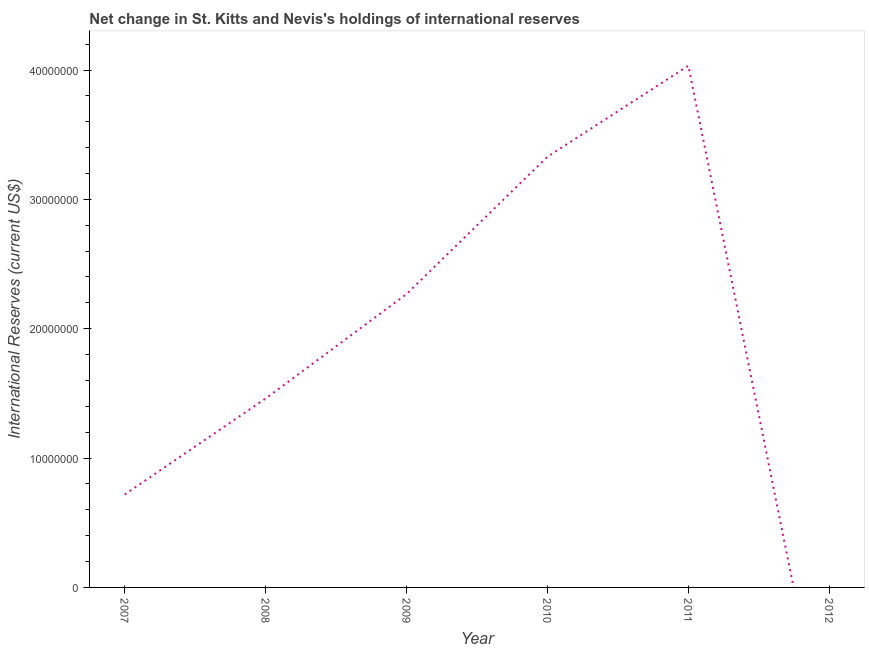What is the reserves and related items in 2007?
Provide a succinct answer. 7.18e+06. Across all years, what is the maximum reserves and related items?
Offer a very short reply. 4.03e+07. Across all years, what is the minimum reserves and related items?
Offer a very short reply. 0. What is the sum of the reserves and related items?
Your answer should be compact. 1.18e+08. What is the difference between the reserves and related items in 2008 and 2010?
Keep it short and to the point. -1.87e+07. What is the average reserves and related items per year?
Give a very brief answer. 1.97e+07. What is the median reserves and related items?
Provide a short and direct response. 1.86e+07. In how many years, is the reserves and related items greater than 22000000 US$?
Provide a succinct answer. 3. What is the ratio of the reserves and related items in 2008 to that in 2010?
Provide a short and direct response. 0.44. Is the reserves and related items in 2007 less than that in 2011?
Make the answer very short. Yes. Is the difference between the reserves and related items in 2008 and 2010 greater than the difference between any two years?
Offer a terse response. No. What is the difference between the highest and the second highest reserves and related items?
Your response must be concise. 7.03e+06. Is the sum of the reserves and related items in 2008 and 2011 greater than the maximum reserves and related items across all years?
Your answer should be very brief. Yes. What is the difference between the highest and the lowest reserves and related items?
Give a very brief answer. 4.03e+07. In how many years, is the reserves and related items greater than the average reserves and related items taken over all years?
Provide a short and direct response. 3. Does the reserves and related items monotonically increase over the years?
Keep it short and to the point. No. What is the title of the graph?
Keep it short and to the point. Net change in St. Kitts and Nevis's holdings of international reserves. What is the label or title of the X-axis?
Your answer should be very brief. Year. What is the label or title of the Y-axis?
Give a very brief answer. International Reserves (current US$). What is the International Reserves (current US$) in 2007?
Make the answer very short. 7.18e+06. What is the International Reserves (current US$) of 2008?
Your answer should be compact. 1.46e+07. What is the International Reserves (current US$) of 2009?
Provide a short and direct response. 2.27e+07. What is the International Reserves (current US$) in 2010?
Offer a terse response. 3.33e+07. What is the International Reserves (current US$) of 2011?
Give a very brief answer. 4.03e+07. What is the International Reserves (current US$) in 2012?
Give a very brief answer. 0. What is the difference between the International Reserves (current US$) in 2007 and 2008?
Provide a succinct answer. -7.42e+06. What is the difference between the International Reserves (current US$) in 2007 and 2009?
Your response must be concise. -1.55e+07. What is the difference between the International Reserves (current US$) in 2007 and 2010?
Give a very brief answer. -2.61e+07. What is the difference between the International Reserves (current US$) in 2007 and 2011?
Keep it short and to the point. -3.32e+07. What is the difference between the International Reserves (current US$) in 2008 and 2009?
Offer a terse response. -8.07e+06. What is the difference between the International Reserves (current US$) in 2008 and 2010?
Ensure brevity in your answer.  -1.87e+07. What is the difference between the International Reserves (current US$) in 2008 and 2011?
Provide a succinct answer. -2.57e+07. What is the difference between the International Reserves (current US$) in 2009 and 2010?
Provide a short and direct response. -1.06e+07. What is the difference between the International Reserves (current US$) in 2009 and 2011?
Provide a short and direct response. -1.77e+07. What is the difference between the International Reserves (current US$) in 2010 and 2011?
Give a very brief answer. -7.03e+06. What is the ratio of the International Reserves (current US$) in 2007 to that in 2008?
Offer a very short reply. 0.49. What is the ratio of the International Reserves (current US$) in 2007 to that in 2009?
Provide a short and direct response. 0.32. What is the ratio of the International Reserves (current US$) in 2007 to that in 2010?
Provide a short and direct response. 0.22. What is the ratio of the International Reserves (current US$) in 2007 to that in 2011?
Your answer should be very brief. 0.18. What is the ratio of the International Reserves (current US$) in 2008 to that in 2009?
Your answer should be very brief. 0.64. What is the ratio of the International Reserves (current US$) in 2008 to that in 2010?
Offer a terse response. 0.44. What is the ratio of the International Reserves (current US$) in 2008 to that in 2011?
Ensure brevity in your answer.  0.36. What is the ratio of the International Reserves (current US$) in 2009 to that in 2010?
Ensure brevity in your answer.  0.68. What is the ratio of the International Reserves (current US$) in 2009 to that in 2011?
Provide a short and direct response. 0.56. What is the ratio of the International Reserves (current US$) in 2010 to that in 2011?
Give a very brief answer. 0.83. 